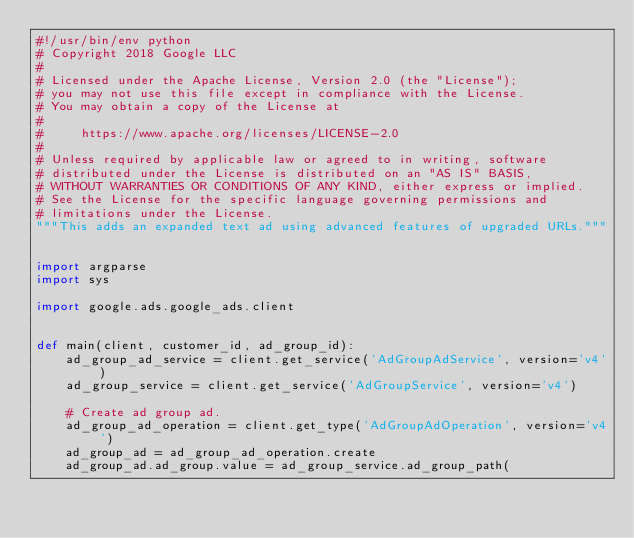Convert code to text. <code><loc_0><loc_0><loc_500><loc_500><_Python_>#!/usr/bin/env python
# Copyright 2018 Google LLC
#
# Licensed under the Apache License, Version 2.0 (the "License");
# you may not use this file except in compliance with the License.
# You may obtain a copy of the License at
#
#     https://www.apache.org/licenses/LICENSE-2.0
#
# Unless required by applicable law or agreed to in writing, software
# distributed under the License is distributed on an "AS IS" BASIS,
# WITHOUT WARRANTIES OR CONDITIONS OF ANY KIND, either express or implied.
# See the License for the specific language governing permissions and
# limitations under the License.
"""This adds an expanded text ad using advanced features of upgraded URLs."""


import argparse
import sys

import google.ads.google_ads.client


def main(client, customer_id, ad_group_id):
    ad_group_ad_service = client.get_service('AdGroupAdService', version='v4')
    ad_group_service = client.get_service('AdGroupService', version='v4')

    # Create ad group ad.
    ad_group_ad_operation = client.get_type('AdGroupAdOperation', version='v4')
    ad_group_ad = ad_group_ad_operation.create
    ad_group_ad.ad_group.value = ad_group_service.ad_group_path(</code> 